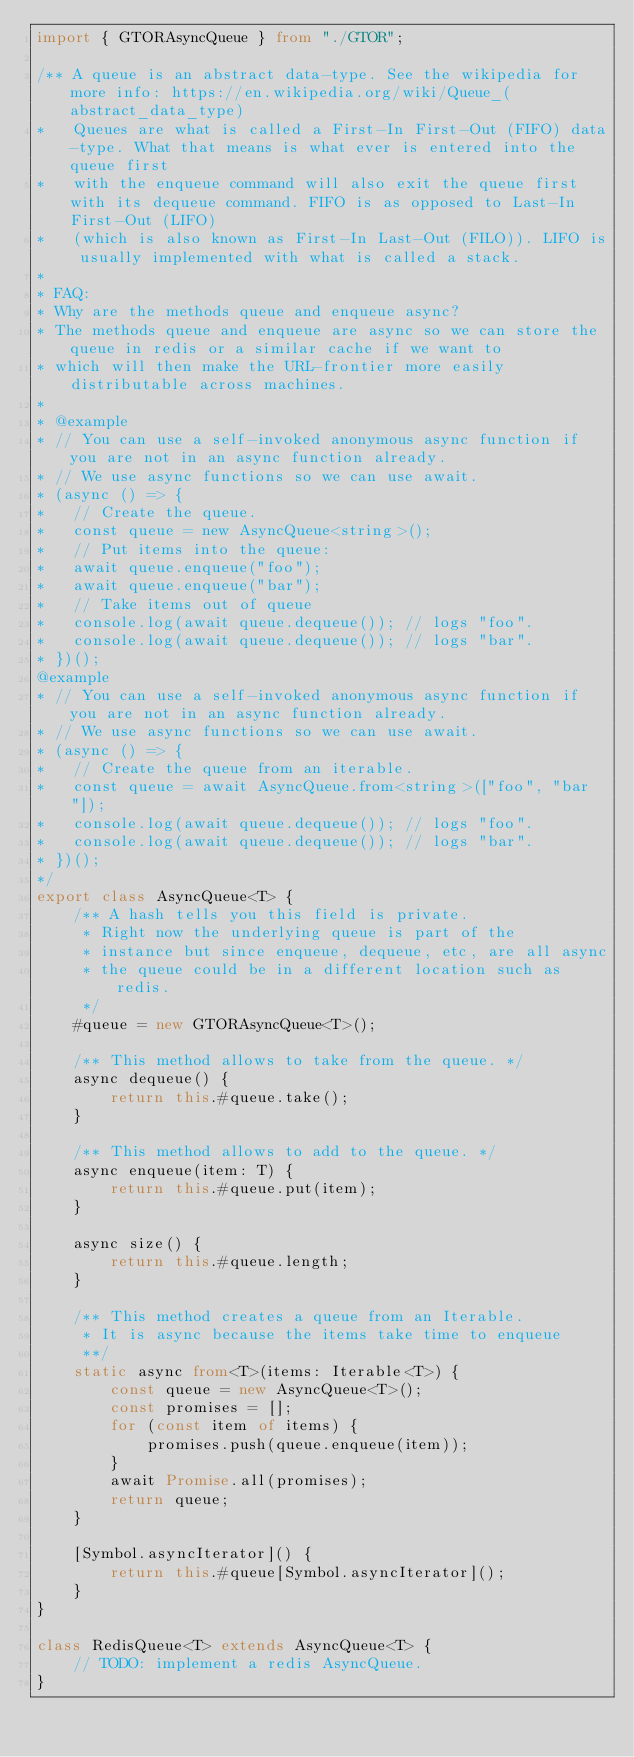Convert code to text. <code><loc_0><loc_0><loc_500><loc_500><_TypeScript_>import { GTORAsyncQueue } from "./GTOR";

/** A queue is an abstract data-type. See the wikipedia for more info: https://en.wikipedia.org/wiki/Queue_(abstract_data_type)
*   Queues are what is called a First-In First-Out (FIFO) data-type. What that means is what ever is entered into the queue first 
*   with the enqueue command will also exit the queue first with its dequeue command. FIFO is as opposed to Last-In First-Out (LIFO)
*   (which is also known as First-In Last-Out (FILO)). LIFO is usually implemented with what is called a stack.
*
* FAQ:
* Why are the methods queue and enqueue async?
* The methods queue and enqueue are async so we can store the queue in redis or a similar cache if we want to
* which will then make the URL-frontier more easily distributable across machines. 
*
* @example
* // You can use a self-invoked anonymous async function if you are not in an async function already.
* // We use async functions so we can use await.
* (async () => {
*   // Create the queue.
*   const queue = new AsyncQueue<string>();
*   // Put items into the queue:
*   await queue.enqueue("foo");
*   await queue.enqueue("bar");
*   // Take items out of queue
*   console.log(await queue.dequeue()); // logs "foo".
*   console.log(await queue.dequeue()); // logs "bar".
* })();
@example
* // You can use a self-invoked anonymous async function if you are not in an async function already.
* // We use async functions so we can use await.
* (async () => {
*   // Create the queue from an iterable.
*   const queue = await AsyncQueue.from<string>(["foo", "bar"]);
*   console.log(await queue.dequeue()); // logs "foo".
*   console.log(await queue.dequeue()); // logs "bar".
* })();
*/
export class AsyncQueue<T> {
	/** A hash tells you this field is private.
	 * Right now the underlying queue is part of the
	 * instance but since enqueue, dequeue, etc, are all async
	 * the queue could be in a different location such as redis.
	 */
	#queue = new GTORAsyncQueue<T>();

	/** This method allows to take from the queue. */
	async dequeue() {
		return this.#queue.take();
	}

	/** This method allows to add to the queue. */
	async enqueue(item: T) {
		return this.#queue.put(item);
	}

	async size() {
		return this.#queue.length;
	}

	/** This method creates a queue from an Iterable.
	 * It is async because the items take time to enqueue
	 **/
	static async from<T>(items: Iterable<T>) {
		const queue = new AsyncQueue<T>();
		const promises = [];
		for (const item of items) {
			promises.push(queue.enqueue(item));
		}
		await Promise.all(promises);
		return queue;
	}

	[Symbol.asyncIterator]() {
		return this.#queue[Symbol.asyncIterator]();
	}
}

class RedisQueue<T> extends AsyncQueue<T> {
	// TODO: implement a redis AsyncQueue.
}
</code> 